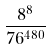<formula> <loc_0><loc_0><loc_500><loc_500>\frac { 8 ^ { 8 } } { 7 6 ^ { 4 8 0 } }</formula> 